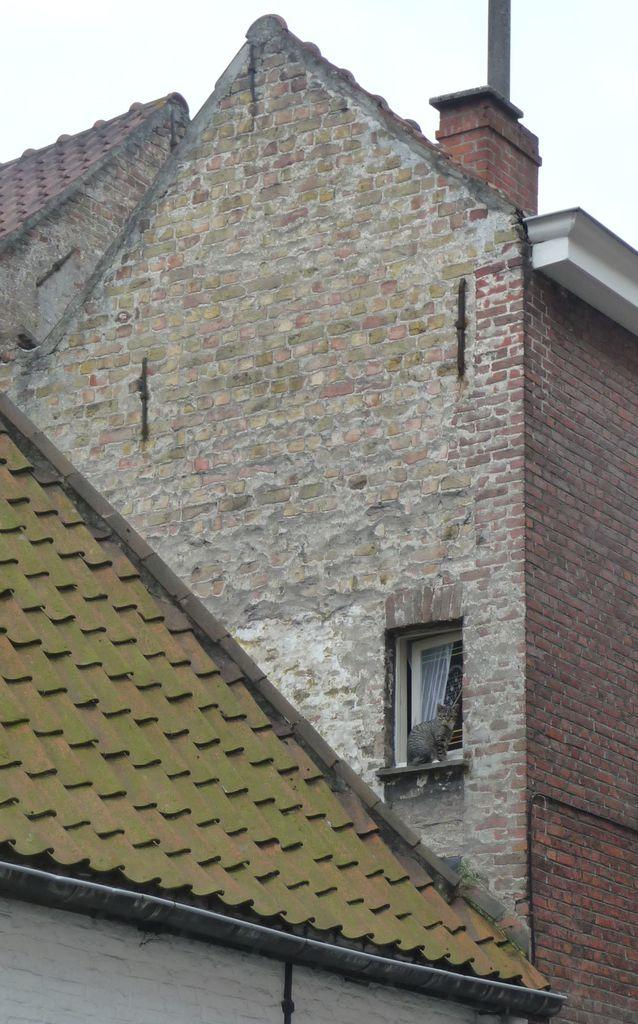What is the main structure in the image? There is a building in the image. What feature can be seen on the building? The building has windows. What is the color of the sky in the image? The sky is white in color. Can you see any fairies swimming in the sky in the image? There are no fairies or swimming activity present in the image; it features a building with windows and a white sky. 